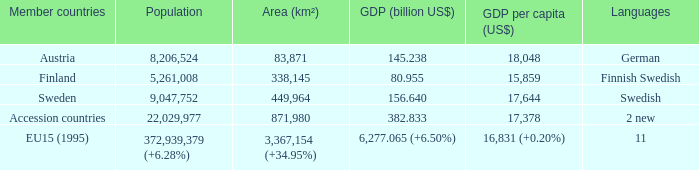Specify the member states for finnish-swedish. Finland. 